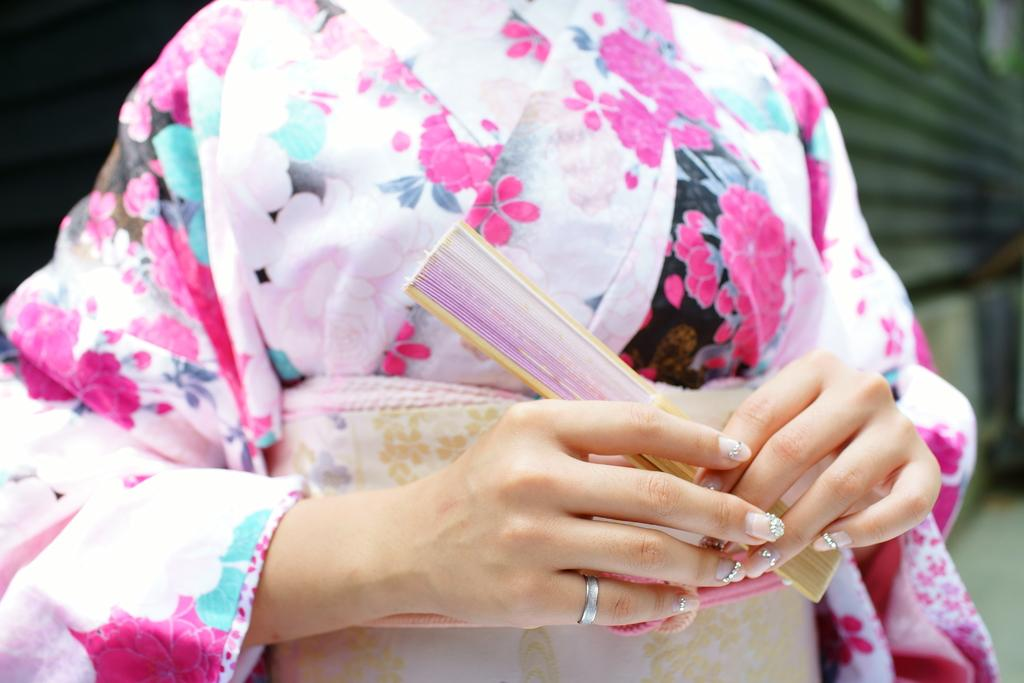Who is the main subject in the image? There is a woman in the image. What is the woman doing in the image? The woman is standing in the image. What is the woman holding in the image? The woman is holding an object in the image. What type of line can be seen connecting the woman to the cherry in the image? There is no cherry or line connecting the woman to any object in the image. 